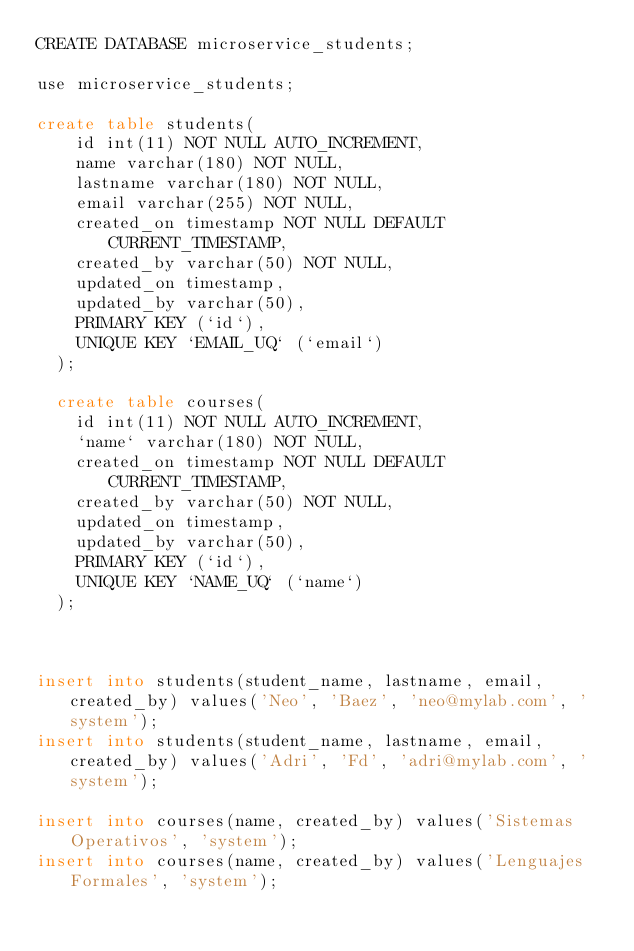<code> <loc_0><loc_0><loc_500><loc_500><_SQL_>CREATE DATABASE microservice_students;

use microservice_students;

create table students(
    id int(11) NOT NULL AUTO_INCREMENT,
    name varchar(180) NOT NULL,
    lastname varchar(180) NOT NULL,
    email varchar(255) NOT NULL,
    created_on timestamp NOT NULL DEFAULT CURRENT_TIMESTAMP,
    created_by varchar(50) NOT NULL,
    updated_on timestamp,
    updated_by varchar(50),
    PRIMARY KEY (`id`),
    UNIQUE KEY `EMAIL_UQ` (`email`)
  ); 
  
  create table courses(
    id int(11) NOT NULL AUTO_INCREMENT,
    `name` varchar(180) NOT NULL,
    created_on timestamp NOT NULL DEFAULT CURRENT_TIMESTAMP,
    created_by varchar(50) NOT NULL,
    updated_on timestamp,
    updated_by varchar(50),
    PRIMARY KEY (`id`),
    UNIQUE KEY `NAME_UQ` (`name`)
  ); 



insert into students(student_name, lastname, email, created_by) values('Neo', 'Baez', 'neo@mylab.com', 'system');
insert into students(student_name, lastname, email, created_by) values('Adri', 'Fd', 'adri@mylab.com', 'system');

insert into courses(name, created_by) values('Sistemas Operativos', 'system');
insert into courses(name, created_by) values('Lenguajes Formales', 'system');
</code> 